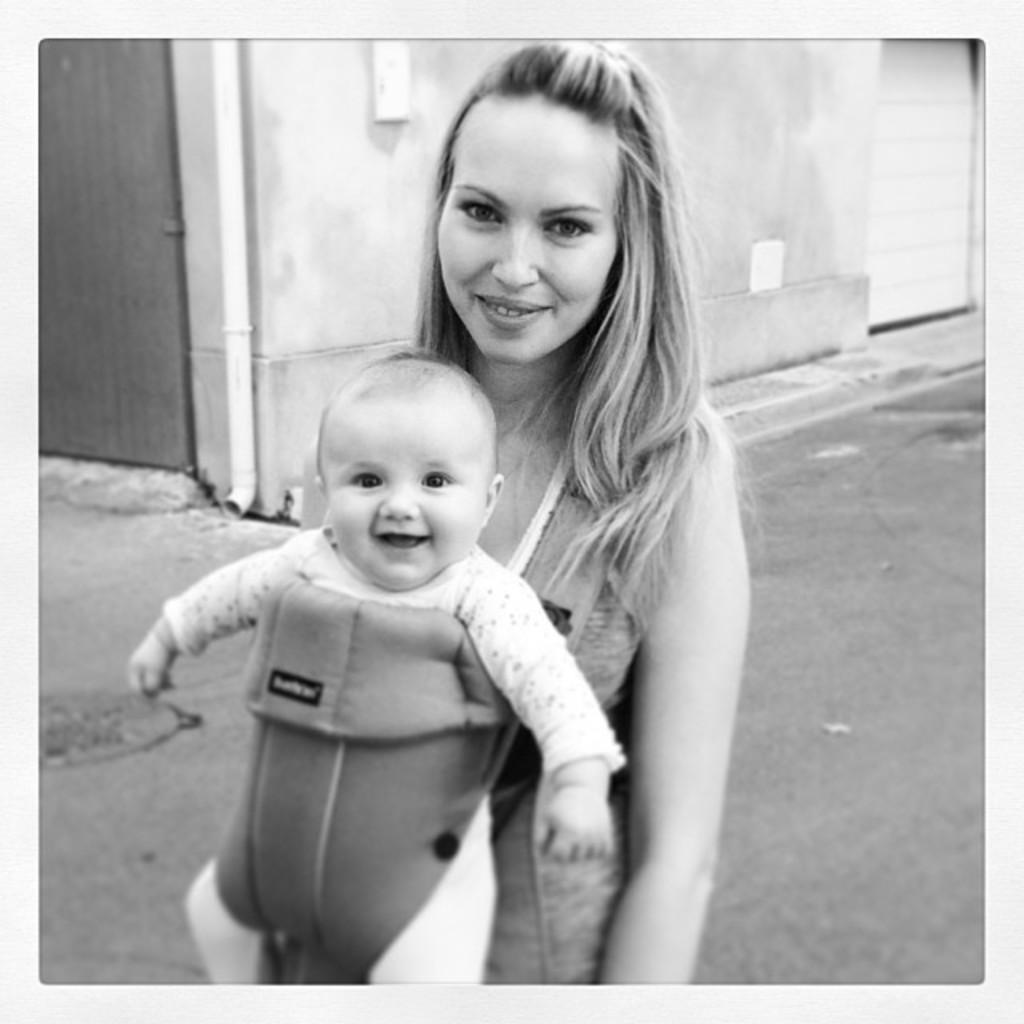What type of structure is visible in the image? There is a building in the image. What else can be seen besides the building? There is a pole and two objects attached to the wall in the image. How many doors are present in the image? There are two doors in the image. What is the woman standing on the road doing? The woman is standing on the road and carrying a baby. What type of goose can be seen playing with friends made of copper in the image? There is no goose or copper friends present in the image. 